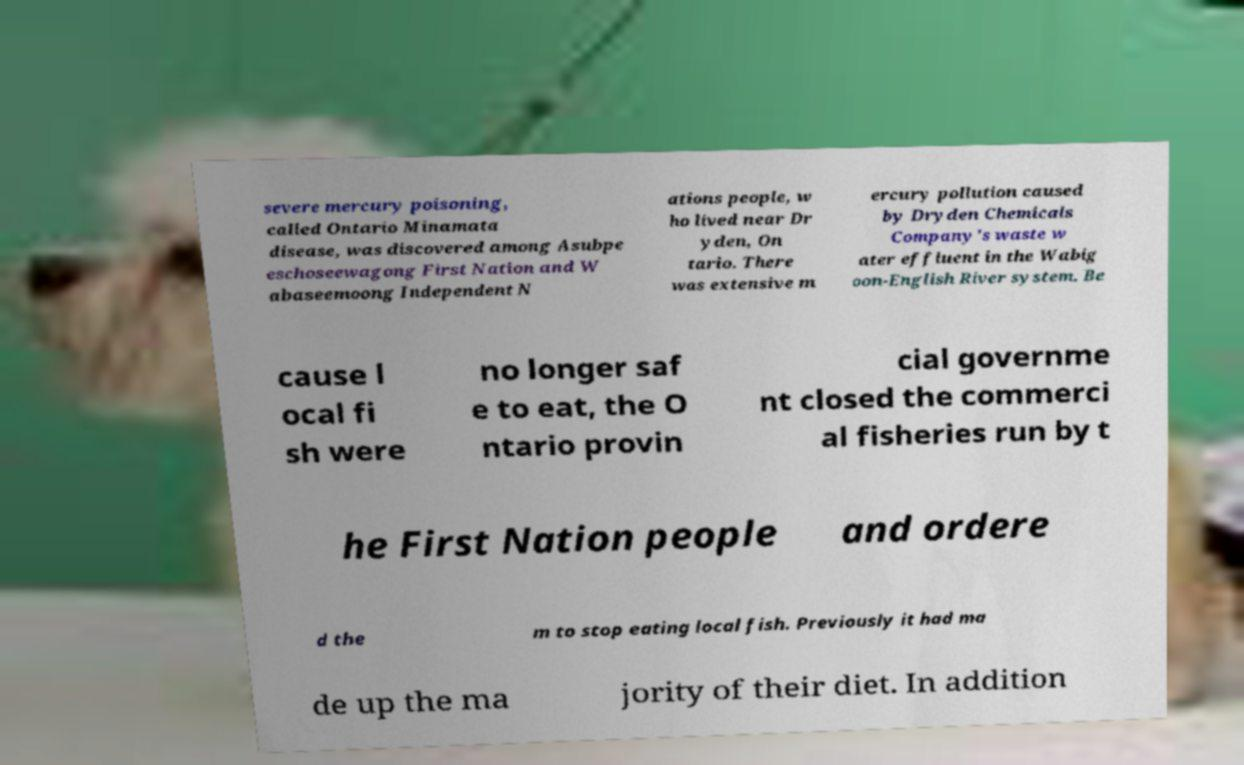What messages or text are displayed in this image? I need them in a readable, typed format. severe mercury poisoning, called Ontario Minamata disease, was discovered among Asubpe eschoseewagong First Nation and W abaseemoong Independent N ations people, w ho lived near Dr yden, On tario. There was extensive m ercury pollution caused by Dryden Chemicals Company's waste w ater effluent in the Wabig oon-English River system. Be cause l ocal fi sh were no longer saf e to eat, the O ntario provin cial governme nt closed the commerci al fisheries run by t he First Nation people and ordere d the m to stop eating local fish. Previously it had ma de up the ma jority of their diet. In addition 